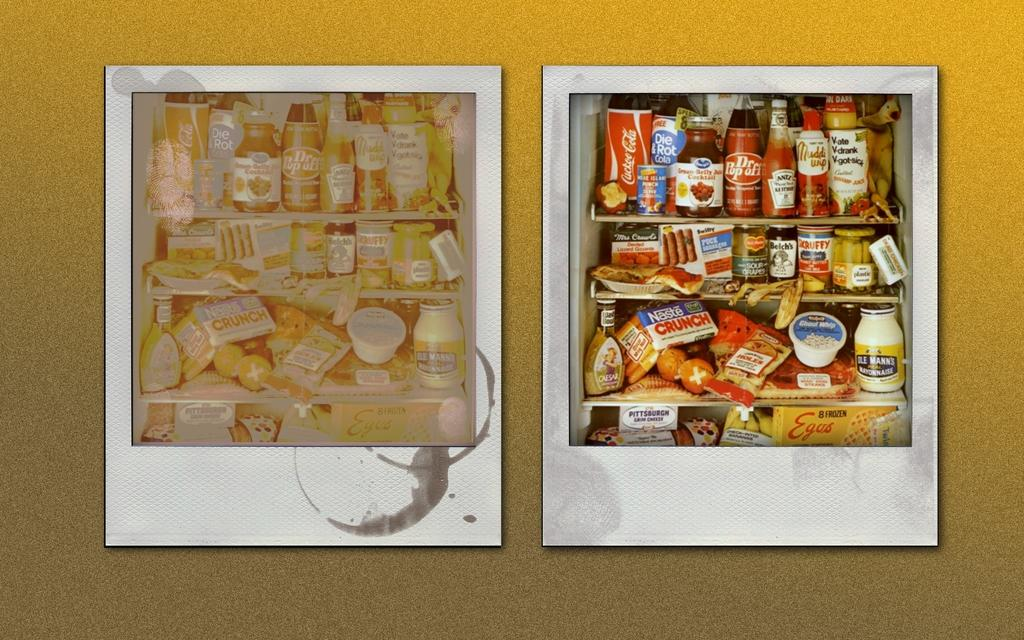<image>
Render a clear and concise summary of the photo. Two photos of the same refrigerator filled with food such as a Nestle Crunch Bar. 